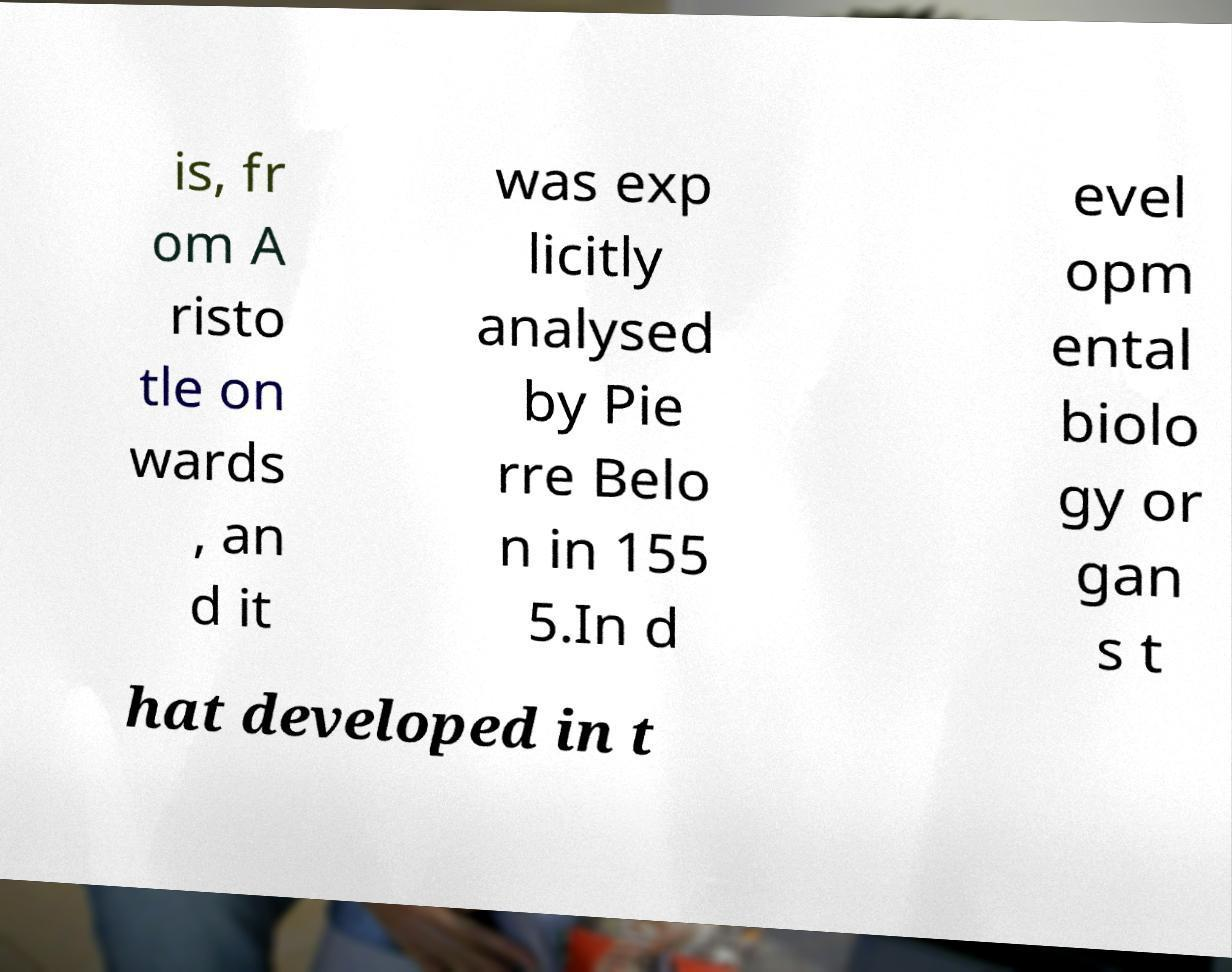For documentation purposes, I need the text within this image transcribed. Could you provide that? is, fr om A risto tle on wards , an d it was exp licitly analysed by Pie rre Belo n in 155 5.In d evel opm ental biolo gy or gan s t hat developed in t 